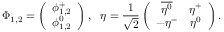<formula> <loc_0><loc_0><loc_500><loc_500>\Phi _ { 1 , 2 } = \left ( \begin{array} { c } { { \phi _ { 1 , 2 } ^ { + } } } \\ { { \phi _ { 1 , 2 } ^ { 0 } } } \end{array} \right ) , \eta = { \frac { 1 } { \sqrt { 2 } } } \left ( \begin{array} { c c } { { \overline { { { \eta ^ { 0 } } } } } } & { { \eta ^ { + } } } \\ { { - \eta ^ { - } } } & { { \eta ^ { 0 } } } \end{array} \right ) .</formula> 